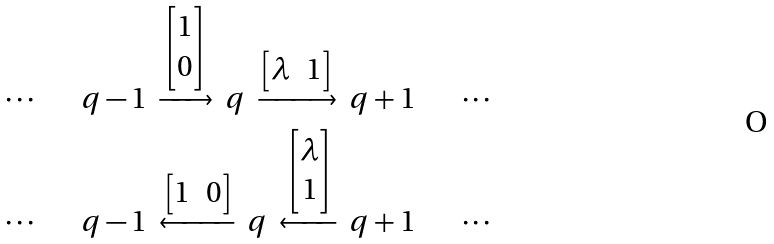<formula> <loc_0><loc_0><loc_500><loc_500>\cdots \ { \quad } \ q - 1 \ \xrightarrow { \begin{bmatrix} 1 \\ 0 \end{bmatrix} } \ q \ \xrightarrow { \begin{bmatrix} \lambda & 1 \end{bmatrix} } \ q + 1 \ { \quad } \ \cdots \\ \cdots \ { \quad } \ q - 1 \ \xleftarrow { \begin{bmatrix} 1 & 0 \end{bmatrix} } \ q \ \xleftarrow { \begin{bmatrix} \lambda \\ 1 \end{bmatrix} } \ q + 1 \ { \quad } \ \cdots</formula> 